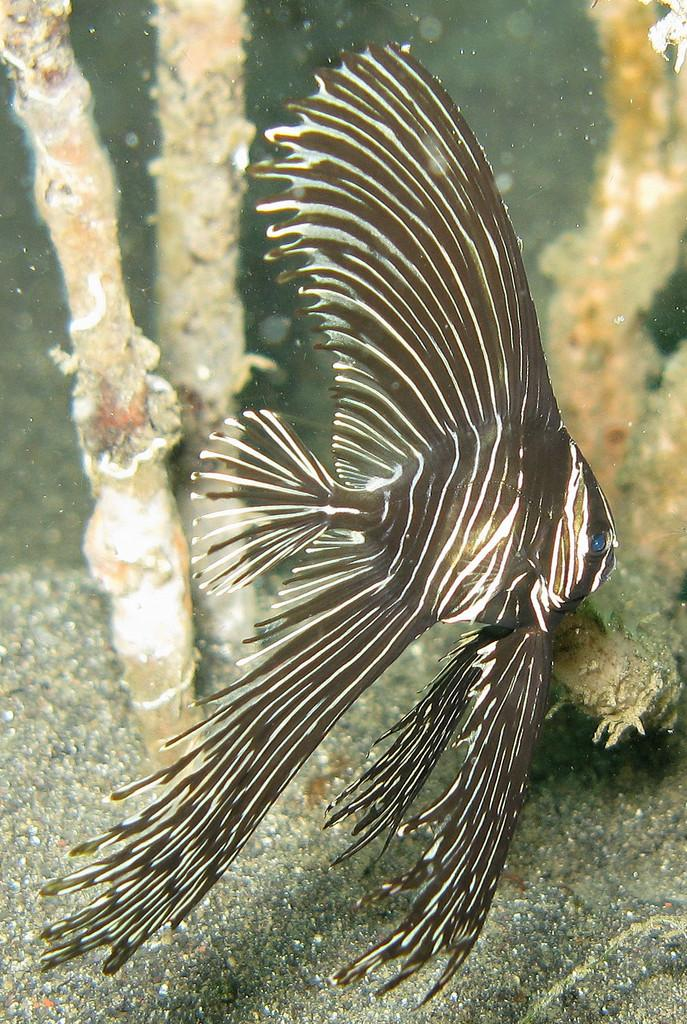What type of animal is present in the image? There is a fish in the image. What else can be seen in the image besides the fish? There are corals in the image. What type of cart can be seen carrying a bun in the image? There is no cart, bun, or goat present in the image; it features a fish and corals. 